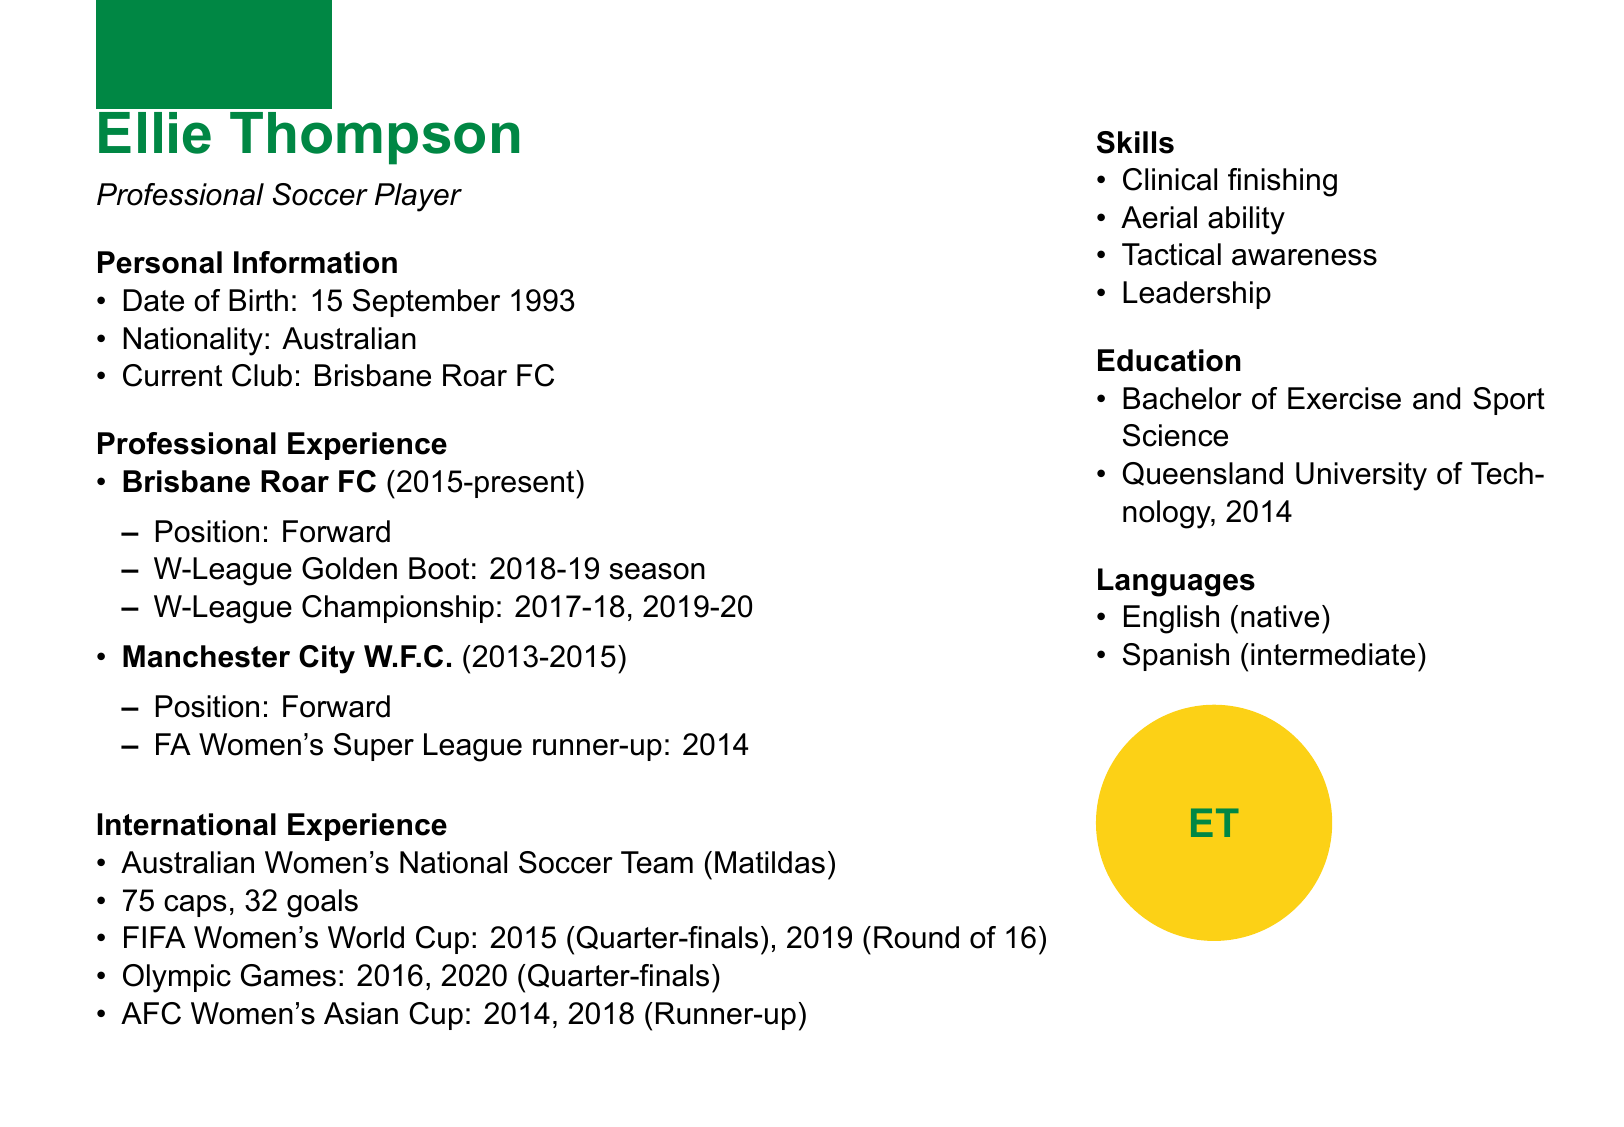what is Ellie Thompson's date of birth? Ellie Thompson's date of birth can be found under personal information in the document.
Answer: 15 September 1993 how many goals has Ellie scored for the Matildas? The number of goals scored for the Matildas is listed in the international experience section.
Answer: 32 goals what position does Ellie play at Brisbane Roar FC? The position played by Ellie at Brisbane Roar FC is specified in the professional experience section.
Answer: Forward how many caps does Ellie have for the Matildas? The total number of caps for the Matildas is mentioned in the international experience part of the document.
Answer: 75 caps which club did Ellie play for before Brisbane Roar FC? The club Ellie played for prior to Brisbane Roar FC is listed in the professional experience section.
Answer: Manchester City W.F.C what major tournament did Ellie participate in during 2019? The major tournaments Ellie participated in are listed in the international experience section, specifically highlighting the year.
Answer: FIFA Women's World Cup how many W-League Championships has Ellie won? The number of W-League Championships won by Ellie is detailed in the professional experience section.
Answer: 2 what language does Ellie speak at an intermediate level? The languages spoken by Ellie can be found in the languages section of the document.
Answer: Spanish 